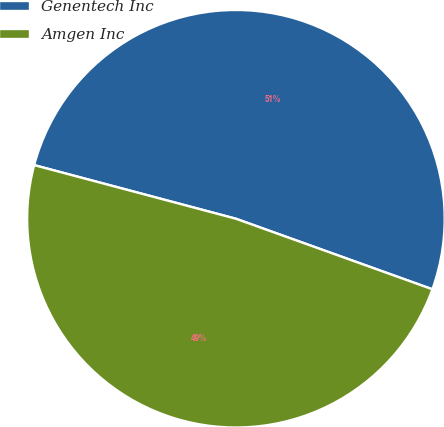Convert chart. <chart><loc_0><loc_0><loc_500><loc_500><pie_chart><fcel>Genentech Inc<fcel>Amgen Inc<nl><fcel>51.35%<fcel>48.65%<nl></chart> 